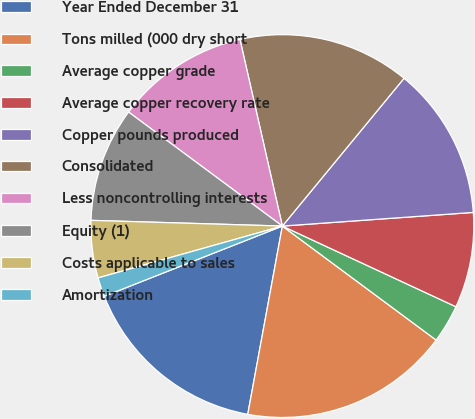Convert chart to OTSL. <chart><loc_0><loc_0><loc_500><loc_500><pie_chart><fcel>Year Ended December 31<fcel>Tons milled (000 dry short<fcel>Average copper grade<fcel>Average copper recovery rate<fcel>Copper pounds produced<fcel>Consolidated<fcel>Less noncontrolling interests<fcel>Equity (1)<fcel>Costs applicable to sales<fcel>Amortization<nl><fcel>16.13%<fcel>17.74%<fcel>3.23%<fcel>8.06%<fcel>12.9%<fcel>14.52%<fcel>11.29%<fcel>9.68%<fcel>4.84%<fcel>1.61%<nl></chart> 